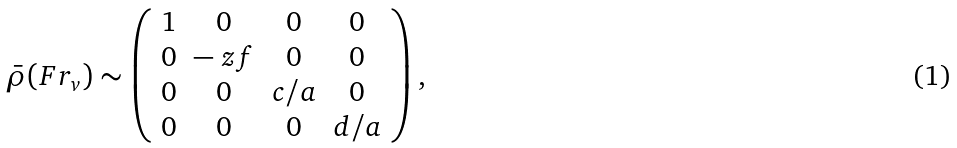Convert formula to latex. <formula><loc_0><loc_0><loc_500><loc_500>\bar { \rho } ( F r _ { v } ) \sim \left ( \begin{array} { c c c c } 1 & 0 & 0 & 0 \\ 0 & - \ z f & 0 & 0 \\ 0 & 0 & c / a & 0 \\ 0 & 0 & 0 & d / a \\ \end{array} \right ) ,</formula> 